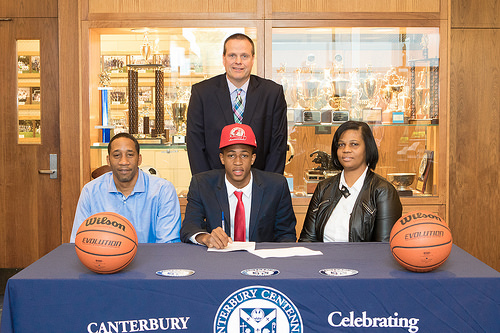<image>
Is the table behind the ball? No. The table is not behind the ball. From this viewpoint, the table appears to be positioned elsewhere in the scene. 